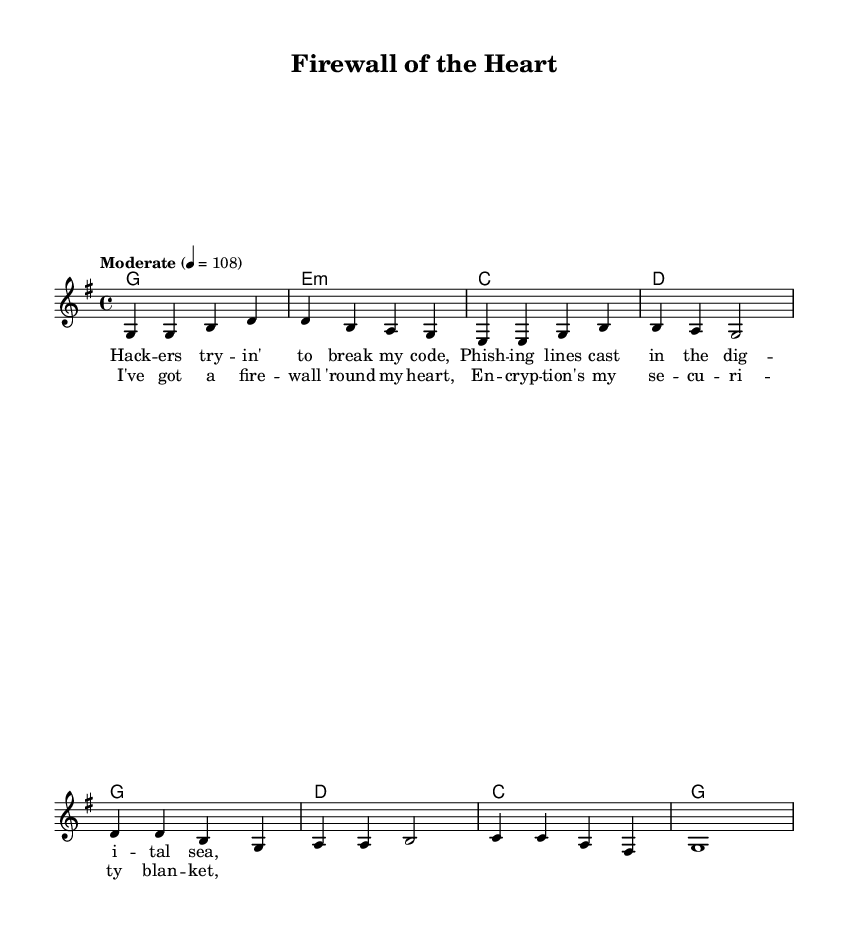What is the key signature of this music? The key signature is G major, which has one sharp (F#). This is indicated at the beginning of the staff where the key signature is shown.
Answer: G major What is the time signature of this music? The time signature is 4/4, which is indicated at the beginning of the sheet music. This means there are four beats per measure and each beat is a quarter note.
Answer: 4/4 What is the tempo marking for this piece? The tempo marking is "Moderate" with a metronome marking of 108 beats per minute, which is indicated in the global music settings.
Answer: Moderate How many measures are in the verse section? The verse section consists of four measures, as indicated by the notation in the melody. Each group of notes separated by vertical lines (bars) counts as one measure.
Answer: Four What is the first lyric line in the chorus? The first lyric line in the chorus is "I've got a fire -- wall 'round my heart," which is found under the corresponding melody notes of the chorus.
Answer: I've got a fire -- wall 'round my heart What chord follows the first measure of the verse? The chord following the first measure of the verse is G major. This corresponds with the chord symbols written above the melody notes in the measure.
Answer: G Which songwriting elements are used to express cybersecurity themes in the lyrics? The lyrics illustrate cybersecurity themes through metaphors like "firewall" and "encryption." These terms describe protective measures and are commonly associated with digital protection.
Answer: Firewall, encryption 